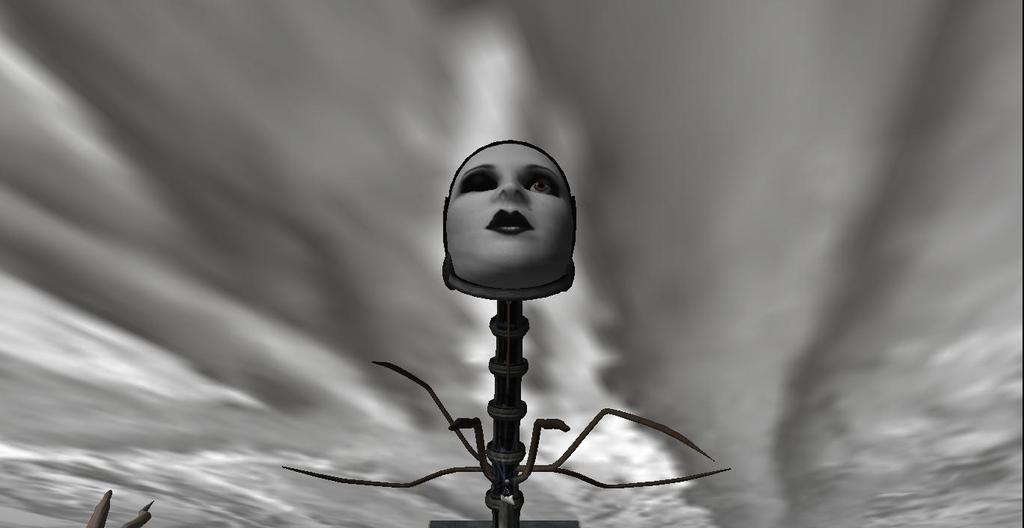In one or two sentences, can you explain what this image depicts? In this image, we can see an object. In the background, we can see a sky which is cloudy. 